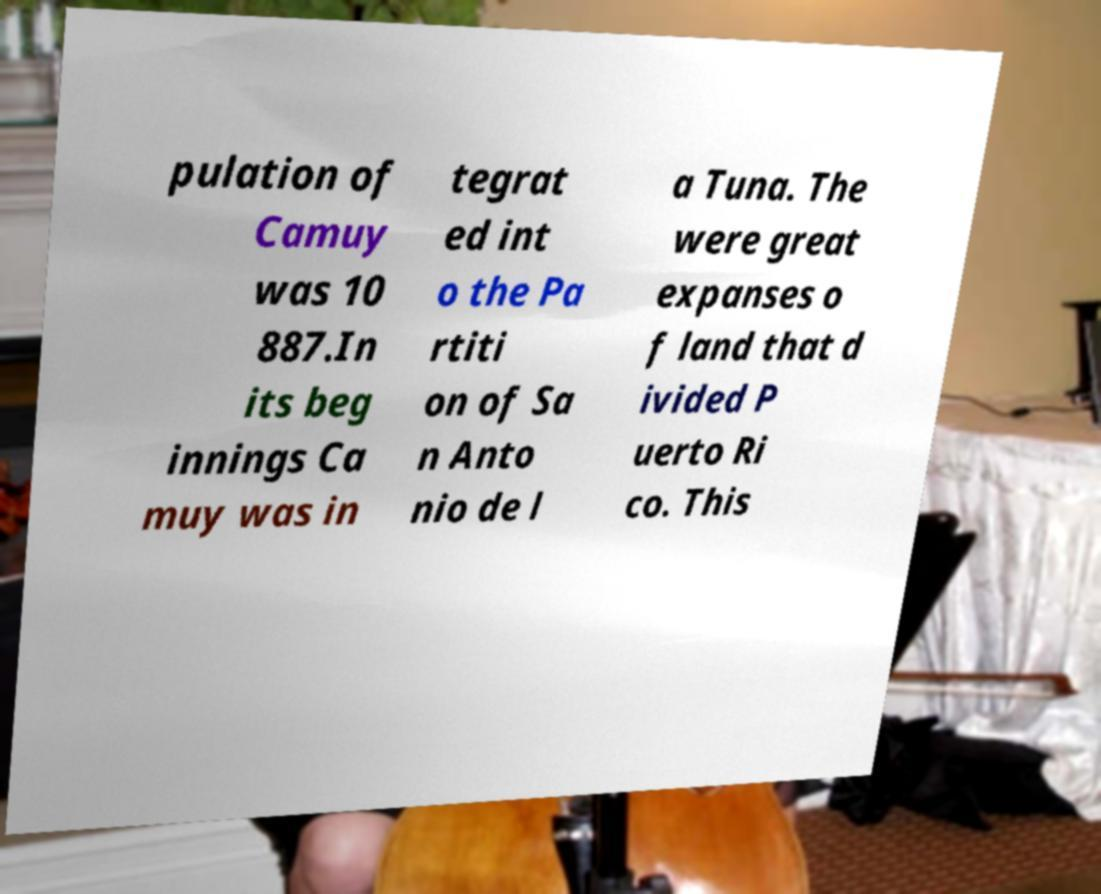I need the written content from this picture converted into text. Can you do that? pulation of Camuy was 10 887.In its beg innings Ca muy was in tegrat ed int o the Pa rtiti on of Sa n Anto nio de l a Tuna. The were great expanses o f land that d ivided P uerto Ri co. This 